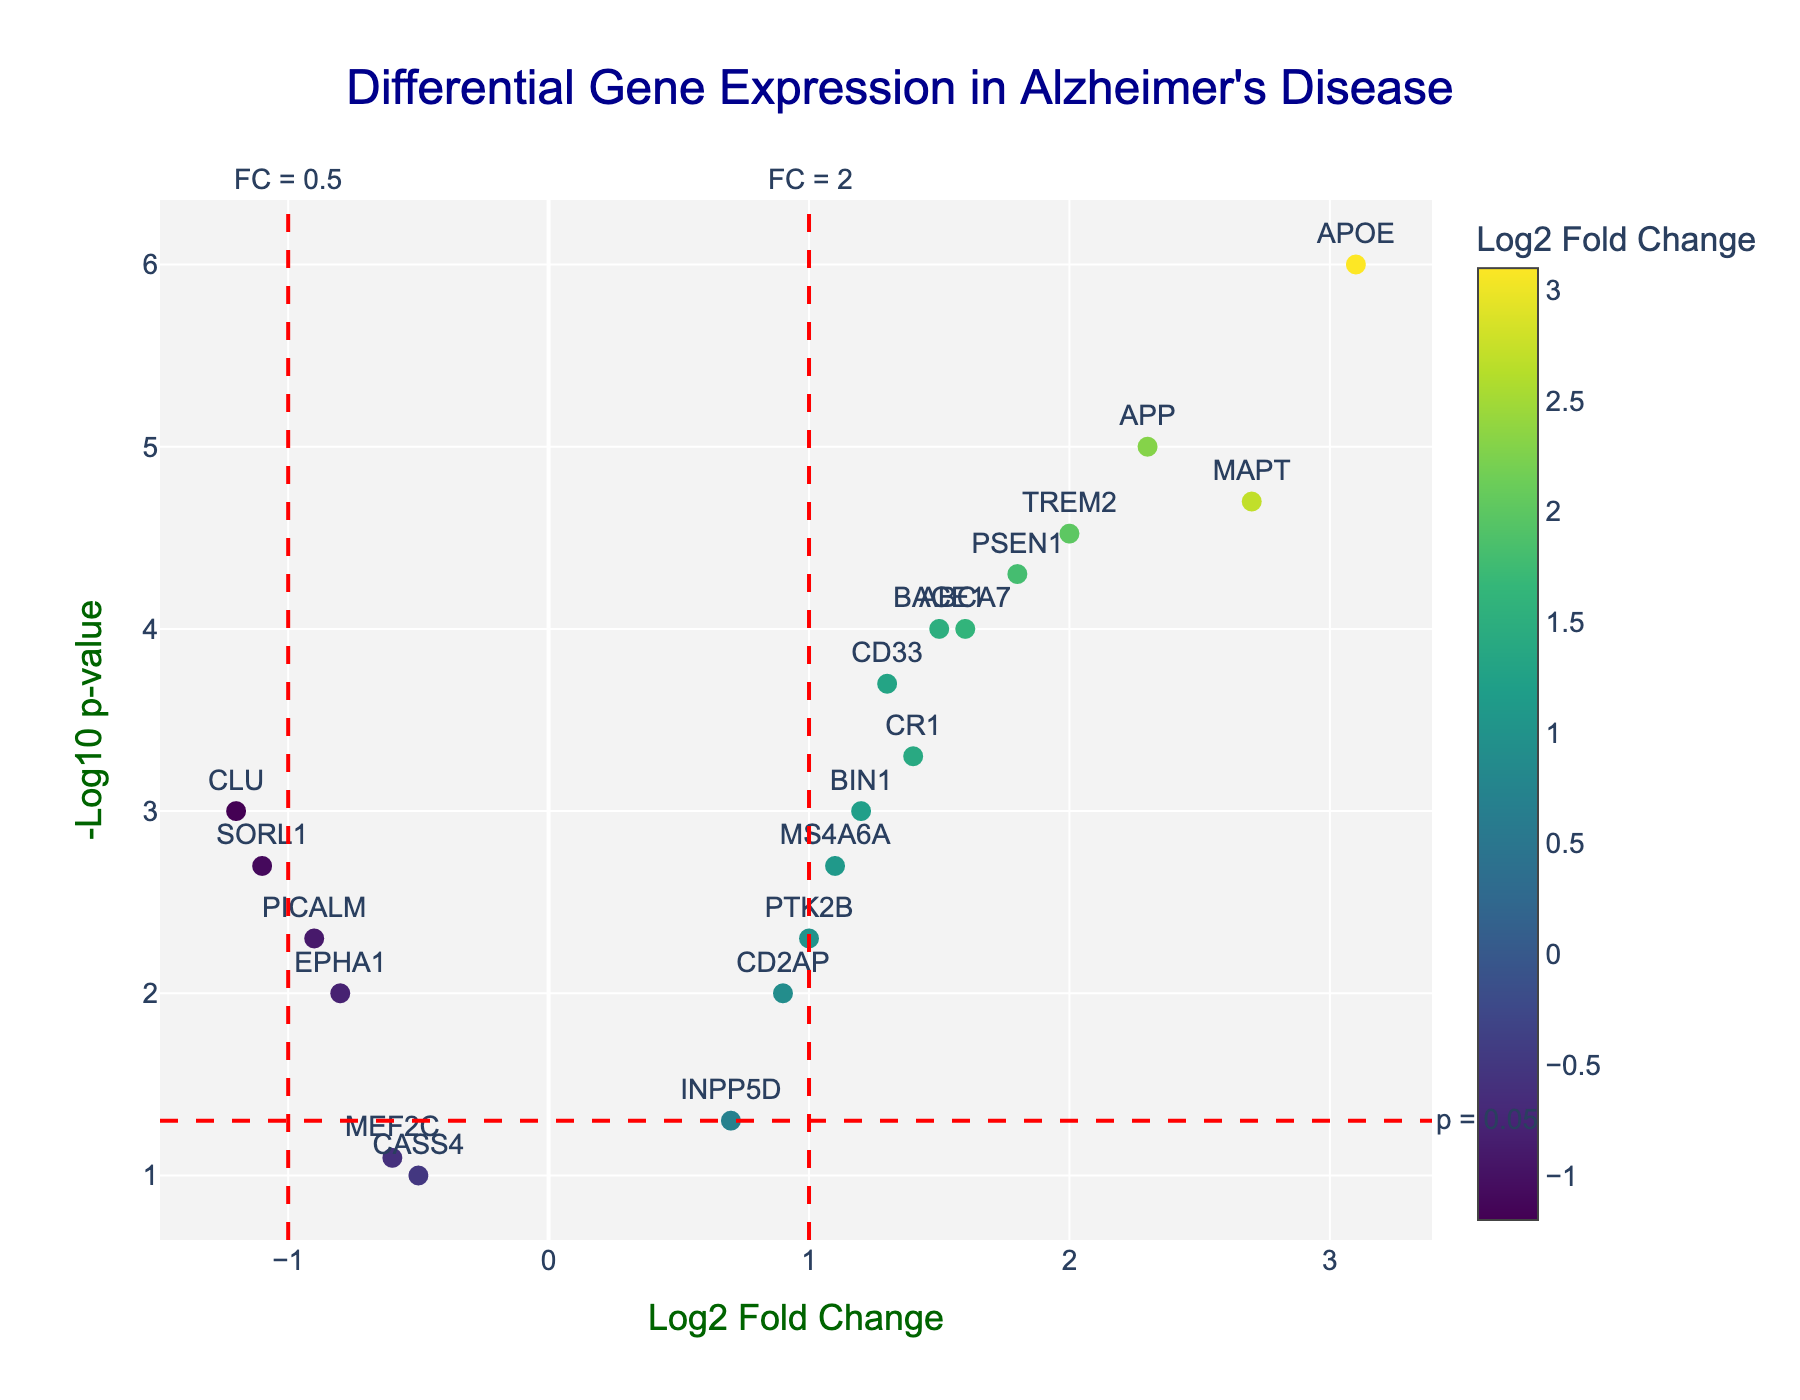What is the title of the figure? The title is usually located at the top of the plot and provides a summary of what the figure represents. In this case, the title of the figure is displayed prominently.
Answer: Differential Gene Expression in Alzheimer's Disease How many genes show significant differential expression with a p-value less than 0.05? All genes with a p-value less than 0.05 will appear above the red horizontal threshold at y = -log10(0.05) on the plot. Count the number of such points.
Answer: 15 Which gene has the highest log2 fold change? Observe the x-axis values and identify the data point with the highest log2 fold change. Look for the corresponding gene label.
Answer: APOE Which gene has the lowest p-value and what is its significance level on the plot? The lowest p-value corresponds to the highest -log10(p-value) on the y-axis. Identify this data point and check its corresponding gene and p-value.
Answer: APOE, p-value = 0.000001 How many genes are upregulated with a log2 fold change greater than 1 and a p-value less than 0.05? Look for data points to the right of the vertical line at log2 fold change of 1 and above the horizontal line at -log10(p-value) of -log10(0.05). Count these points.
Answer: 8 How many genes are downregulated with a log2 fold change less than -1 and a p-value less than 0.05? Locate the data points to the left of the vertical line at log2 fold change of -1 and above the horizontal line at -log10(p-value) of -log10(0.05). Count these points.
Answer: 3 Which gene(s) show borderline significance with a p-value around 0.05, and what are their log2 fold changes? Find points near the threshold line -log10(p-value) of -log10(0.05) and check their log2 fold change values.
Answer: INPP5D, log2 fold change = 0.7; MEF2C, log2 fold change = -0.6; CASS4, log2 fold change = -0.5 Are there any genes with log2 fold change close to 0 but significant p-values? Locate points near the log2 fold change of 0 on the x-axis and check if they fall above the -log10(p-value) threshold line.
Answer: Yes, PTK2B, CD2AP Which gene has a log2 fold change closest to 2.3, and what is its p-value? Identify the gene with a log2 fold change value closest to 2.3 by observing the x-axis values and check its corresponding p-value.
Answer: APP, p-value = 0.00001 